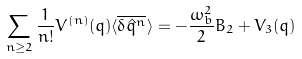Convert formula to latex. <formula><loc_0><loc_0><loc_500><loc_500>\sum _ { n \geq 2 } \frac { 1 } { n ! } V ^ { ( n ) } ( q ) \langle \overline { \delta \hat { q } ^ { n } } \rangle = - \frac { \omega _ { b } ^ { 2 } } { 2 } B _ { 2 } + V _ { 3 } ( q )</formula> 